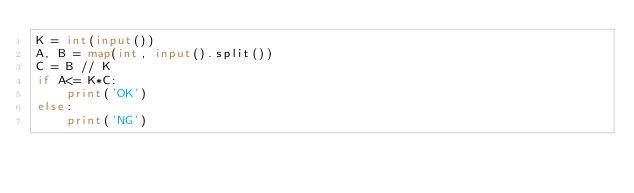Convert code to text. <code><loc_0><loc_0><loc_500><loc_500><_Python_>K = int(input())
A, B = map(int, input().split())
C = B // K
if A<= K*C:
    print('OK')
else:
    print('NG')</code> 